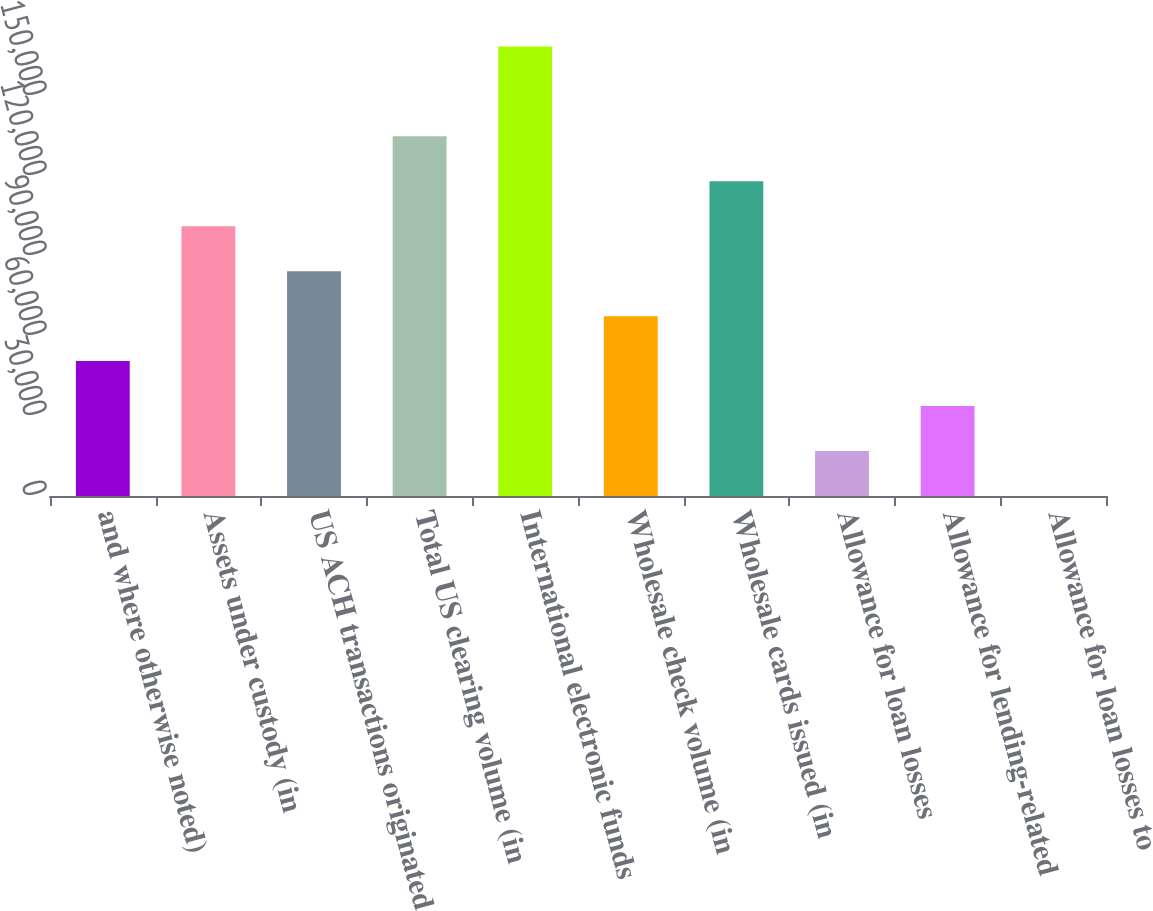Convert chart. <chart><loc_0><loc_0><loc_500><loc_500><bar_chart><fcel>and where otherwise noted)<fcel>Assets under custody (in<fcel>US ACH transactions originated<fcel>Total US clearing volume (in<fcel>International electronic funds<fcel>Wholesale check volume (in<fcel>Wholesale cards issued (in<fcel>Allowance for loan losses<fcel>Allowance for lending-related<fcel>Allowance for loan losses to<nl><fcel>50581.6<fcel>101163<fcel>84302.5<fcel>134884<fcel>168605<fcel>67442.1<fcel>118024<fcel>16860.6<fcel>33721.1<fcel>0.09<nl></chart> 